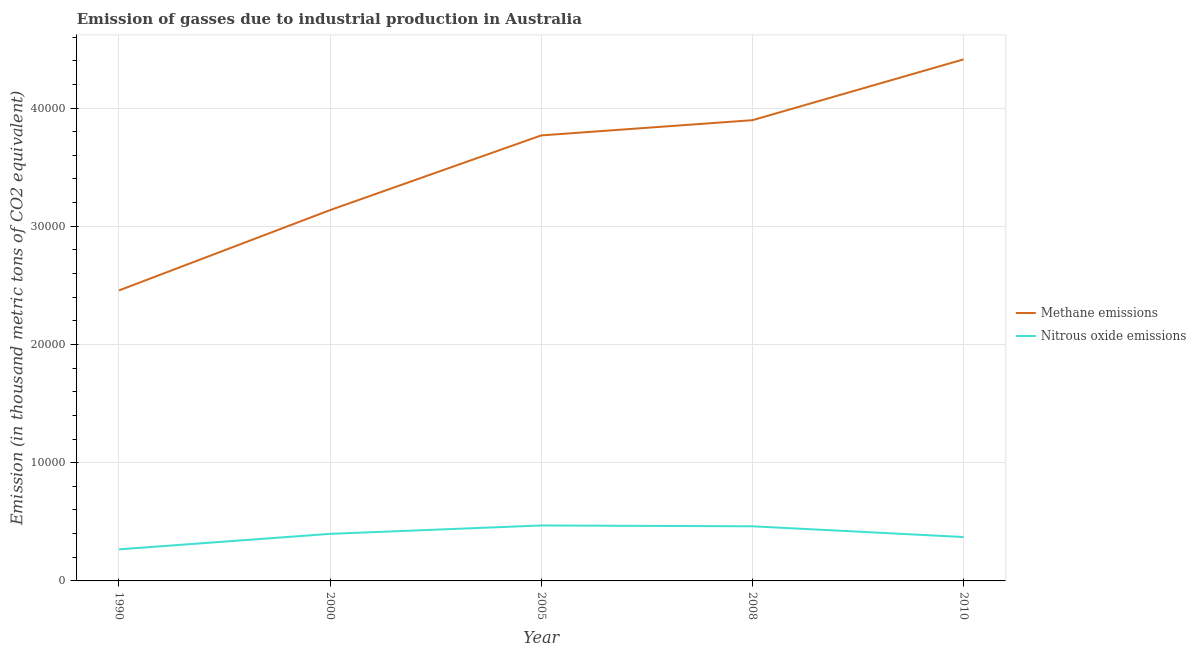How many different coloured lines are there?
Offer a terse response. 2. Is the number of lines equal to the number of legend labels?
Provide a succinct answer. Yes. What is the amount of nitrous oxide emissions in 1990?
Ensure brevity in your answer.  2671. Across all years, what is the maximum amount of nitrous oxide emissions?
Offer a very short reply. 4690.1. Across all years, what is the minimum amount of methane emissions?
Your answer should be compact. 2.46e+04. In which year was the amount of methane emissions maximum?
Give a very brief answer. 2010. What is the total amount of methane emissions in the graph?
Give a very brief answer. 1.77e+05. What is the difference between the amount of methane emissions in 1990 and that in 2010?
Offer a terse response. -1.95e+04. What is the difference between the amount of nitrous oxide emissions in 2010 and the amount of methane emissions in 2000?
Your response must be concise. -2.77e+04. What is the average amount of nitrous oxide emissions per year?
Your response must be concise. 3935.56. In the year 1990, what is the difference between the amount of methane emissions and amount of nitrous oxide emissions?
Offer a very short reply. 2.19e+04. In how many years, is the amount of nitrous oxide emissions greater than 36000 thousand metric tons?
Ensure brevity in your answer.  0. What is the ratio of the amount of nitrous oxide emissions in 2000 to that in 2008?
Give a very brief answer. 0.86. What is the difference between the highest and the second highest amount of nitrous oxide emissions?
Provide a short and direct response. 69.1. What is the difference between the highest and the lowest amount of methane emissions?
Ensure brevity in your answer.  1.95e+04. In how many years, is the amount of nitrous oxide emissions greater than the average amount of nitrous oxide emissions taken over all years?
Offer a very short reply. 3. Is the sum of the amount of methane emissions in 2005 and 2010 greater than the maximum amount of nitrous oxide emissions across all years?
Your response must be concise. Yes. Does the amount of nitrous oxide emissions monotonically increase over the years?
Offer a terse response. No. Is the amount of methane emissions strictly greater than the amount of nitrous oxide emissions over the years?
Offer a very short reply. Yes. Is the amount of nitrous oxide emissions strictly less than the amount of methane emissions over the years?
Offer a very short reply. Yes. How many lines are there?
Ensure brevity in your answer.  2. How many years are there in the graph?
Offer a very short reply. 5. Does the graph contain any zero values?
Your answer should be very brief. No. Does the graph contain grids?
Offer a terse response. Yes. How many legend labels are there?
Give a very brief answer. 2. What is the title of the graph?
Keep it short and to the point. Emission of gasses due to industrial production in Australia. Does "Female entrants" appear as one of the legend labels in the graph?
Provide a short and direct response. No. What is the label or title of the X-axis?
Make the answer very short. Year. What is the label or title of the Y-axis?
Your answer should be compact. Emission (in thousand metric tons of CO2 equivalent). What is the Emission (in thousand metric tons of CO2 equivalent) of Methane emissions in 1990?
Your answer should be compact. 2.46e+04. What is the Emission (in thousand metric tons of CO2 equivalent) in Nitrous oxide emissions in 1990?
Your answer should be very brief. 2671. What is the Emission (in thousand metric tons of CO2 equivalent) in Methane emissions in 2000?
Offer a terse response. 3.14e+04. What is the Emission (in thousand metric tons of CO2 equivalent) in Nitrous oxide emissions in 2000?
Provide a succinct answer. 3981.7. What is the Emission (in thousand metric tons of CO2 equivalent) of Methane emissions in 2005?
Give a very brief answer. 3.77e+04. What is the Emission (in thousand metric tons of CO2 equivalent) of Nitrous oxide emissions in 2005?
Ensure brevity in your answer.  4690.1. What is the Emission (in thousand metric tons of CO2 equivalent) of Methane emissions in 2008?
Give a very brief answer. 3.90e+04. What is the Emission (in thousand metric tons of CO2 equivalent) in Nitrous oxide emissions in 2008?
Your answer should be very brief. 4621. What is the Emission (in thousand metric tons of CO2 equivalent) in Methane emissions in 2010?
Your answer should be very brief. 4.41e+04. What is the Emission (in thousand metric tons of CO2 equivalent) in Nitrous oxide emissions in 2010?
Offer a very short reply. 3714. Across all years, what is the maximum Emission (in thousand metric tons of CO2 equivalent) in Methane emissions?
Your answer should be very brief. 4.41e+04. Across all years, what is the maximum Emission (in thousand metric tons of CO2 equivalent) in Nitrous oxide emissions?
Your answer should be very brief. 4690.1. Across all years, what is the minimum Emission (in thousand metric tons of CO2 equivalent) of Methane emissions?
Give a very brief answer. 2.46e+04. Across all years, what is the minimum Emission (in thousand metric tons of CO2 equivalent) in Nitrous oxide emissions?
Offer a very short reply. 2671. What is the total Emission (in thousand metric tons of CO2 equivalent) in Methane emissions in the graph?
Your answer should be compact. 1.77e+05. What is the total Emission (in thousand metric tons of CO2 equivalent) of Nitrous oxide emissions in the graph?
Your answer should be compact. 1.97e+04. What is the difference between the Emission (in thousand metric tons of CO2 equivalent) of Methane emissions in 1990 and that in 2000?
Ensure brevity in your answer.  -6797.8. What is the difference between the Emission (in thousand metric tons of CO2 equivalent) of Nitrous oxide emissions in 1990 and that in 2000?
Give a very brief answer. -1310.7. What is the difference between the Emission (in thousand metric tons of CO2 equivalent) in Methane emissions in 1990 and that in 2005?
Offer a terse response. -1.31e+04. What is the difference between the Emission (in thousand metric tons of CO2 equivalent) of Nitrous oxide emissions in 1990 and that in 2005?
Give a very brief answer. -2019.1. What is the difference between the Emission (in thousand metric tons of CO2 equivalent) in Methane emissions in 1990 and that in 2008?
Provide a short and direct response. -1.44e+04. What is the difference between the Emission (in thousand metric tons of CO2 equivalent) of Nitrous oxide emissions in 1990 and that in 2008?
Offer a very short reply. -1950. What is the difference between the Emission (in thousand metric tons of CO2 equivalent) of Methane emissions in 1990 and that in 2010?
Your answer should be very brief. -1.95e+04. What is the difference between the Emission (in thousand metric tons of CO2 equivalent) of Nitrous oxide emissions in 1990 and that in 2010?
Provide a short and direct response. -1043. What is the difference between the Emission (in thousand metric tons of CO2 equivalent) of Methane emissions in 2000 and that in 2005?
Ensure brevity in your answer.  -6316.4. What is the difference between the Emission (in thousand metric tons of CO2 equivalent) in Nitrous oxide emissions in 2000 and that in 2005?
Make the answer very short. -708.4. What is the difference between the Emission (in thousand metric tons of CO2 equivalent) of Methane emissions in 2000 and that in 2008?
Your answer should be compact. -7602.4. What is the difference between the Emission (in thousand metric tons of CO2 equivalent) of Nitrous oxide emissions in 2000 and that in 2008?
Offer a very short reply. -639.3. What is the difference between the Emission (in thousand metric tons of CO2 equivalent) of Methane emissions in 2000 and that in 2010?
Make the answer very short. -1.27e+04. What is the difference between the Emission (in thousand metric tons of CO2 equivalent) of Nitrous oxide emissions in 2000 and that in 2010?
Your answer should be compact. 267.7. What is the difference between the Emission (in thousand metric tons of CO2 equivalent) of Methane emissions in 2005 and that in 2008?
Offer a terse response. -1286. What is the difference between the Emission (in thousand metric tons of CO2 equivalent) in Nitrous oxide emissions in 2005 and that in 2008?
Provide a succinct answer. 69.1. What is the difference between the Emission (in thousand metric tons of CO2 equivalent) in Methane emissions in 2005 and that in 2010?
Provide a short and direct response. -6430.6. What is the difference between the Emission (in thousand metric tons of CO2 equivalent) in Nitrous oxide emissions in 2005 and that in 2010?
Make the answer very short. 976.1. What is the difference between the Emission (in thousand metric tons of CO2 equivalent) of Methane emissions in 2008 and that in 2010?
Give a very brief answer. -5144.6. What is the difference between the Emission (in thousand metric tons of CO2 equivalent) of Nitrous oxide emissions in 2008 and that in 2010?
Provide a succinct answer. 907. What is the difference between the Emission (in thousand metric tons of CO2 equivalent) in Methane emissions in 1990 and the Emission (in thousand metric tons of CO2 equivalent) in Nitrous oxide emissions in 2000?
Your answer should be very brief. 2.06e+04. What is the difference between the Emission (in thousand metric tons of CO2 equivalent) in Methane emissions in 1990 and the Emission (in thousand metric tons of CO2 equivalent) in Nitrous oxide emissions in 2005?
Ensure brevity in your answer.  1.99e+04. What is the difference between the Emission (in thousand metric tons of CO2 equivalent) in Methane emissions in 1990 and the Emission (in thousand metric tons of CO2 equivalent) in Nitrous oxide emissions in 2008?
Provide a succinct answer. 1.99e+04. What is the difference between the Emission (in thousand metric tons of CO2 equivalent) of Methane emissions in 1990 and the Emission (in thousand metric tons of CO2 equivalent) of Nitrous oxide emissions in 2010?
Make the answer very short. 2.09e+04. What is the difference between the Emission (in thousand metric tons of CO2 equivalent) in Methane emissions in 2000 and the Emission (in thousand metric tons of CO2 equivalent) in Nitrous oxide emissions in 2005?
Keep it short and to the point. 2.67e+04. What is the difference between the Emission (in thousand metric tons of CO2 equivalent) in Methane emissions in 2000 and the Emission (in thousand metric tons of CO2 equivalent) in Nitrous oxide emissions in 2008?
Make the answer very short. 2.67e+04. What is the difference between the Emission (in thousand metric tons of CO2 equivalent) of Methane emissions in 2000 and the Emission (in thousand metric tons of CO2 equivalent) of Nitrous oxide emissions in 2010?
Your response must be concise. 2.77e+04. What is the difference between the Emission (in thousand metric tons of CO2 equivalent) of Methane emissions in 2005 and the Emission (in thousand metric tons of CO2 equivalent) of Nitrous oxide emissions in 2008?
Keep it short and to the point. 3.31e+04. What is the difference between the Emission (in thousand metric tons of CO2 equivalent) in Methane emissions in 2005 and the Emission (in thousand metric tons of CO2 equivalent) in Nitrous oxide emissions in 2010?
Keep it short and to the point. 3.40e+04. What is the difference between the Emission (in thousand metric tons of CO2 equivalent) of Methane emissions in 2008 and the Emission (in thousand metric tons of CO2 equivalent) of Nitrous oxide emissions in 2010?
Give a very brief answer. 3.53e+04. What is the average Emission (in thousand metric tons of CO2 equivalent) of Methane emissions per year?
Offer a terse response. 3.53e+04. What is the average Emission (in thousand metric tons of CO2 equivalent) in Nitrous oxide emissions per year?
Provide a succinct answer. 3935.56. In the year 1990, what is the difference between the Emission (in thousand metric tons of CO2 equivalent) in Methane emissions and Emission (in thousand metric tons of CO2 equivalent) in Nitrous oxide emissions?
Keep it short and to the point. 2.19e+04. In the year 2000, what is the difference between the Emission (in thousand metric tons of CO2 equivalent) of Methane emissions and Emission (in thousand metric tons of CO2 equivalent) of Nitrous oxide emissions?
Your response must be concise. 2.74e+04. In the year 2005, what is the difference between the Emission (in thousand metric tons of CO2 equivalent) of Methane emissions and Emission (in thousand metric tons of CO2 equivalent) of Nitrous oxide emissions?
Ensure brevity in your answer.  3.30e+04. In the year 2008, what is the difference between the Emission (in thousand metric tons of CO2 equivalent) of Methane emissions and Emission (in thousand metric tons of CO2 equivalent) of Nitrous oxide emissions?
Offer a very short reply. 3.43e+04. In the year 2010, what is the difference between the Emission (in thousand metric tons of CO2 equivalent) of Methane emissions and Emission (in thousand metric tons of CO2 equivalent) of Nitrous oxide emissions?
Your response must be concise. 4.04e+04. What is the ratio of the Emission (in thousand metric tons of CO2 equivalent) in Methane emissions in 1990 to that in 2000?
Your answer should be compact. 0.78. What is the ratio of the Emission (in thousand metric tons of CO2 equivalent) in Nitrous oxide emissions in 1990 to that in 2000?
Your answer should be very brief. 0.67. What is the ratio of the Emission (in thousand metric tons of CO2 equivalent) of Methane emissions in 1990 to that in 2005?
Offer a very short reply. 0.65. What is the ratio of the Emission (in thousand metric tons of CO2 equivalent) in Nitrous oxide emissions in 1990 to that in 2005?
Keep it short and to the point. 0.57. What is the ratio of the Emission (in thousand metric tons of CO2 equivalent) in Methane emissions in 1990 to that in 2008?
Your response must be concise. 0.63. What is the ratio of the Emission (in thousand metric tons of CO2 equivalent) of Nitrous oxide emissions in 1990 to that in 2008?
Provide a succinct answer. 0.58. What is the ratio of the Emission (in thousand metric tons of CO2 equivalent) in Methane emissions in 1990 to that in 2010?
Your answer should be compact. 0.56. What is the ratio of the Emission (in thousand metric tons of CO2 equivalent) in Nitrous oxide emissions in 1990 to that in 2010?
Make the answer very short. 0.72. What is the ratio of the Emission (in thousand metric tons of CO2 equivalent) of Methane emissions in 2000 to that in 2005?
Your answer should be very brief. 0.83. What is the ratio of the Emission (in thousand metric tons of CO2 equivalent) in Nitrous oxide emissions in 2000 to that in 2005?
Offer a very short reply. 0.85. What is the ratio of the Emission (in thousand metric tons of CO2 equivalent) of Methane emissions in 2000 to that in 2008?
Offer a very short reply. 0.8. What is the ratio of the Emission (in thousand metric tons of CO2 equivalent) of Nitrous oxide emissions in 2000 to that in 2008?
Provide a short and direct response. 0.86. What is the ratio of the Emission (in thousand metric tons of CO2 equivalent) of Methane emissions in 2000 to that in 2010?
Make the answer very short. 0.71. What is the ratio of the Emission (in thousand metric tons of CO2 equivalent) in Nitrous oxide emissions in 2000 to that in 2010?
Offer a terse response. 1.07. What is the ratio of the Emission (in thousand metric tons of CO2 equivalent) in Methane emissions in 2005 to that in 2010?
Make the answer very short. 0.85. What is the ratio of the Emission (in thousand metric tons of CO2 equivalent) in Nitrous oxide emissions in 2005 to that in 2010?
Ensure brevity in your answer.  1.26. What is the ratio of the Emission (in thousand metric tons of CO2 equivalent) of Methane emissions in 2008 to that in 2010?
Provide a succinct answer. 0.88. What is the ratio of the Emission (in thousand metric tons of CO2 equivalent) of Nitrous oxide emissions in 2008 to that in 2010?
Provide a succinct answer. 1.24. What is the difference between the highest and the second highest Emission (in thousand metric tons of CO2 equivalent) in Methane emissions?
Offer a very short reply. 5144.6. What is the difference between the highest and the second highest Emission (in thousand metric tons of CO2 equivalent) in Nitrous oxide emissions?
Your answer should be compact. 69.1. What is the difference between the highest and the lowest Emission (in thousand metric tons of CO2 equivalent) of Methane emissions?
Make the answer very short. 1.95e+04. What is the difference between the highest and the lowest Emission (in thousand metric tons of CO2 equivalent) in Nitrous oxide emissions?
Make the answer very short. 2019.1. 